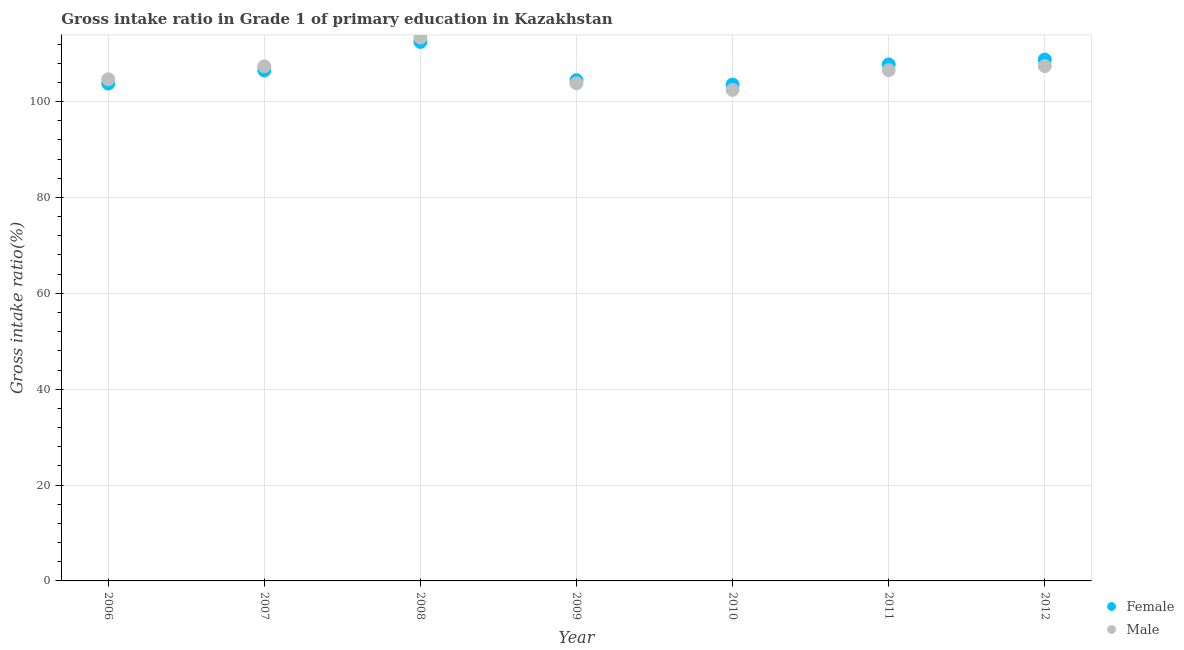Is the number of dotlines equal to the number of legend labels?
Your response must be concise. Yes. What is the gross intake ratio(male) in 2012?
Ensure brevity in your answer.  107.41. Across all years, what is the maximum gross intake ratio(female)?
Keep it short and to the point. 112.46. Across all years, what is the minimum gross intake ratio(female)?
Your answer should be compact. 103.54. In which year was the gross intake ratio(male) minimum?
Make the answer very short. 2010. What is the total gross intake ratio(female) in the graph?
Offer a terse response. 747.31. What is the difference between the gross intake ratio(female) in 2009 and that in 2011?
Keep it short and to the point. -3.28. What is the difference between the gross intake ratio(female) in 2007 and the gross intake ratio(male) in 2009?
Ensure brevity in your answer.  2.71. What is the average gross intake ratio(male) per year?
Offer a very short reply. 106.52. In the year 2009, what is the difference between the gross intake ratio(female) and gross intake ratio(male)?
Provide a succinct answer. 0.66. What is the ratio of the gross intake ratio(male) in 2009 to that in 2010?
Ensure brevity in your answer.  1.01. Is the difference between the gross intake ratio(female) in 2007 and 2011 greater than the difference between the gross intake ratio(male) in 2007 and 2011?
Keep it short and to the point. No. What is the difference between the highest and the second highest gross intake ratio(male)?
Your answer should be compact. 5.96. What is the difference between the highest and the lowest gross intake ratio(male)?
Your answer should be very brief. 10.94. How many dotlines are there?
Give a very brief answer. 2. Does the graph contain grids?
Your answer should be very brief. Yes. How many legend labels are there?
Ensure brevity in your answer.  2. What is the title of the graph?
Offer a terse response. Gross intake ratio in Grade 1 of primary education in Kazakhstan. What is the label or title of the Y-axis?
Ensure brevity in your answer.  Gross intake ratio(%). What is the Gross intake ratio(%) of Female in 2006?
Provide a succinct answer. 103.77. What is the Gross intake ratio(%) of Male in 2006?
Your response must be concise. 104.65. What is the Gross intake ratio(%) in Female in 2007?
Give a very brief answer. 106.53. What is the Gross intake ratio(%) in Male in 2007?
Ensure brevity in your answer.  107.36. What is the Gross intake ratio(%) in Female in 2008?
Offer a terse response. 112.46. What is the Gross intake ratio(%) in Male in 2008?
Your response must be concise. 113.38. What is the Gross intake ratio(%) in Female in 2009?
Offer a terse response. 104.47. What is the Gross intake ratio(%) of Male in 2009?
Provide a short and direct response. 103.82. What is the Gross intake ratio(%) of Female in 2010?
Your response must be concise. 103.54. What is the Gross intake ratio(%) of Male in 2010?
Provide a short and direct response. 102.44. What is the Gross intake ratio(%) in Female in 2011?
Offer a very short reply. 107.76. What is the Gross intake ratio(%) in Male in 2011?
Provide a succinct answer. 106.57. What is the Gross intake ratio(%) in Female in 2012?
Ensure brevity in your answer.  108.77. What is the Gross intake ratio(%) of Male in 2012?
Keep it short and to the point. 107.41. Across all years, what is the maximum Gross intake ratio(%) in Female?
Provide a short and direct response. 112.46. Across all years, what is the maximum Gross intake ratio(%) of Male?
Provide a short and direct response. 113.38. Across all years, what is the minimum Gross intake ratio(%) in Female?
Keep it short and to the point. 103.54. Across all years, what is the minimum Gross intake ratio(%) in Male?
Your answer should be compact. 102.44. What is the total Gross intake ratio(%) in Female in the graph?
Give a very brief answer. 747.31. What is the total Gross intake ratio(%) in Male in the graph?
Keep it short and to the point. 745.63. What is the difference between the Gross intake ratio(%) of Female in 2006 and that in 2007?
Make the answer very short. -2.76. What is the difference between the Gross intake ratio(%) of Male in 2006 and that in 2007?
Offer a very short reply. -2.7. What is the difference between the Gross intake ratio(%) of Female in 2006 and that in 2008?
Make the answer very short. -8.69. What is the difference between the Gross intake ratio(%) in Male in 2006 and that in 2008?
Provide a succinct answer. -8.72. What is the difference between the Gross intake ratio(%) in Female in 2006 and that in 2009?
Give a very brief answer. -0.7. What is the difference between the Gross intake ratio(%) of Male in 2006 and that in 2009?
Offer a very short reply. 0.83. What is the difference between the Gross intake ratio(%) of Female in 2006 and that in 2010?
Your answer should be very brief. 0.23. What is the difference between the Gross intake ratio(%) of Male in 2006 and that in 2010?
Your answer should be very brief. 2.21. What is the difference between the Gross intake ratio(%) in Female in 2006 and that in 2011?
Give a very brief answer. -3.98. What is the difference between the Gross intake ratio(%) in Male in 2006 and that in 2011?
Ensure brevity in your answer.  -1.92. What is the difference between the Gross intake ratio(%) in Female in 2006 and that in 2012?
Your response must be concise. -5. What is the difference between the Gross intake ratio(%) in Male in 2006 and that in 2012?
Your answer should be compact. -2.76. What is the difference between the Gross intake ratio(%) of Female in 2007 and that in 2008?
Ensure brevity in your answer.  -5.93. What is the difference between the Gross intake ratio(%) in Male in 2007 and that in 2008?
Ensure brevity in your answer.  -6.02. What is the difference between the Gross intake ratio(%) in Female in 2007 and that in 2009?
Ensure brevity in your answer.  2.05. What is the difference between the Gross intake ratio(%) in Male in 2007 and that in 2009?
Offer a terse response. 3.54. What is the difference between the Gross intake ratio(%) of Female in 2007 and that in 2010?
Make the answer very short. 2.99. What is the difference between the Gross intake ratio(%) in Male in 2007 and that in 2010?
Make the answer very short. 4.92. What is the difference between the Gross intake ratio(%) of Female in 2007 and that in 2011?
Give a very brief answer. -1.23. What is the difference between the Gross intake ratio(%) of Male in 2007 and that in 2011?
Your answer should be very brief. 0.79. What is the difference between the Gross intake ratio(%) in Female in 2007 and that in 2012?
Provide a succinct answer. -2.24. What is the difference between the Gross intake ratio(%) in Male in 2007 and that in 2012?
Give a very brief answer. -0.06. What is the difference between the Gross intake ratio(%) of Female in 2008 and that in 2009?
Your response must be concise. 7.99. What is the difference between the Gross intake ratio(%) of Male in 2008 and that in 2009?
Your response must be concise. 9.56. What is the difference between the Gross intake ratio(%) of Female in 2008 and that in 2010?
Provide a short and direct response. 8.92. What is the difference between the Gross intake ratio(%) of Male in 2008 and that in 2010?
Keep it short and to the point. 10.94. What is the difference between the Gross intake ratio(%) of Female in 2008 and that in 2011?
Give a very brief answer. 4.71. What is the difference between the Gross intake ratio(%) in Male in 2008 and that in 2011?
Provide a short and direct response. 6.81. What is the difference between the Gross intake ratio(%) of Female in 2008 and that in 2012?
Offer a terse response. 3.69. What is the difference between the Gross intake ratio(%) of Male in 2008 and that in 2012?
Provide a short and direct response. 5.96. What is the difference between the Gross intake ratio(%) in Female in 2009 and that in 2010?
Your answer should be very brief. 0.93. What is the difference between the Gross intake ratio(%) in Male in 2009 and that in 2010?
Your response must be concise. 1.38. What is the difference between the Gross intake ratio(%) of Female in 2009 and that in 2011?
Make the answer very short. -3.28. What is the difference between the Gross intake ratio(%) of Male in 2009 and that in 2011?
Your answer should be very brief. -2.75. What is the difference between the Gross intake ratio(%) in Female in 2009 and that in 2012?
Offer a terse response. -4.3. What is the difference between the Gross intake ratio(%) of Male in 2009 and that in 2012?
Provide a succinct answer. -3.6. What is the difference between the Gross intake ratio(%) of Female in 2010 and that in 2011?
Your answer should be compact. -4.22. What is the difference between the Gross intake ratio(%) of Male in 2010 and that in 2011?
Ensure brevity in your answer.  -4.13. What is the difference between the Gross intake ratio(%) in Female in 2010 and that in 2012?
Provide a succinct answer. -5.23. What is the difference between the Gross intake ratio(%) in Male in 2010 and that in 2012?
Offer a very short reply. -4.97. What is the difference between the Gross intake ratio(%) of Female in 2011 and that in 2012?
Your answer should be very brief. -1.02. What is the difference between the Gross intake ratio(%) in Male in 2011 and that in 2012?
Your answer should be very brief. -0.84. What is the difference between the Gross intake ratio(%) of Female in 2006 and the Gross intake ratio(%) of Male in 2007?
Your answer should be very brief. -3.58. What is the difference between the Gross intake ratio(%) in Female in 2006 and the Gross intake ratio(%) in Male in 2008?
Ensure brevity in your answer.  -9.6. What is the difference between the Gross intake ratio(%) of Female in 2006 and the Gross intake ratio(%) of Male in 2009?
Your response must be concise. -0.04. What is the difference between the Gross intake ratio(%) in Female in 2006 and the Gross intake ratio(%) in Male in 2010?
Make the answer very short. 1.33. What is the difference between the Gross intake ratio(%) of Female in 2006 and the Gross intake ratio(%) of Male in 2011?
Make the answer very short. -2.8. What is the difference between the Gross intake ratio(%) in Female in 2006 and the Gross intake ratio(%) in Male in 2012?
Give a very brief answer. -3.64. What is the difference between the Gross intake ratio(%) in Female in 2007 and the Gross intake ratio(%) in Male in 2008?
Ensure brevity in your answer.  -6.85. What is the difference between the Gross intake ratio(%) of Female in 2007 and the Gross intake ratio(%) of Male in 2009?
Provide a short and direct response. 2.71. What is the difference between the Gross intake ratio(%) of Female in 2007 and the Gross intake ratio(%) of Male in 2010?
Provide a short and direct response. 4.09. What is the difference between the Gross intake ratio(%) in Female in 2007 and the Gross intake ratio(%) in Male in 2011?
Ensure brevity in your answer.  -0.04. What is the difference between the Gross intake ratio(%) of Female in 2007 and the Gross intake ratio(%) of Male in 2012?
Offer a terse response. -0.89. What is the difference between the Gross intake ratio(%) of Female in 2008 and the Gross intake ratio(%) of Male in 2009?
Ensure brevity in your answer.  8.64. What is the difference between the Gross intake ratio(%) of Female in 2008 and the Gross intake ratio(%) of Male in 2010?
Offer a very short reply. 10.02. What is the difference between the Gross intake ratio(%) in Female in 2008 and the Gross intake ratio(%) in Male in 2011?
Offer a very short reply. 5.89. What is the difference between the Gross intake ratio(%) in Female in 2008 and the Gross intake ratio(%) in Male in 2012?
Provide a succinct answer. 5.05. What is the difference between the Gross intake ratio(%) in Female in 2009 and the Gross intake ratio(%) in Male in 2010?
Offer a very short reply. 2.03. What is the difference between the Gross intake ratio(%) in Female in 2009 and the Gross intake ratio(%) in Male in 2011?
Ensure brevity in your answer.  -2.1. What is the difference between the Gross intake ratio(%) of Female in 2009 and the Gross intake ratio(%) of Male in 2012?
Your answer should be compact. -2.94. What is the difference between the Gross intake ratio(%) in Female in 2010 and the Gross intake ratio(%) in Male in 2011?
Your response must be concise. -3.03. What is the difference between the Gross intake ratio(%) in Female in 2010 and the Gross intake ratio(%) in Male in 2012?
Provide a short and direct response. -3.87. What is the difference between the Gross intake ratio(%) in Female in 2011 and the Gross intake ratio(%) in Male in 2012?
Your answer should be very brief. 0.34. What is the average Gross intake ratio(%) of Female per year?
Your answer should be compact. 106.76. What is the average Gross intake ratio(%) of Male per year?
Your response must be concise. 106.52. In the year 2006, what is the difference between the Gross intake ratio(%) of Female and Gross intake ratio(%) of Male?
Provide a short and direct response. -0.88. In the year 2007, what is the difference between the Gross intake ratio(%) of Female and Gross intake ratio(%) of Male?
Ensure brevity in your answer.  -0.83. In the year 2008, what is the difference between the Gross intake ratio(%) in Female and Gross intake ratio(%) in Male?
Make the answer very short. -0.91. In the year 2009, what is the difference between the Gross intake ratio(%) of Female and Gross intake ratio(%) of Male?
Your answer should be very brief. 0.66. In the year 2010, what is the difference between the Gross intake ratio(%) of Female and Gross intake ratio(%) of Male?
Your answer should be compact. 1.1. In the year 2011, what is the difference between the Gross intake ratio(%) in Female and Gross intake ratio(%) in Male?
Make the answer very short. 1.19. In the year 2012, what is the difference between the Gross intake ratio(%) in Female and Gross intake ratio(%) in Male?
Give a very brief answer. 1.36. What is the ratio of the Gross intake ratio(%) of Female in 2006 to that in 2007?
Your response must be concise. 0.97. What is the ratio of the Gross intake ratio(%) in Male in 2006 to that in 2007?
Make the answer very short. 0.97. What is the ratio of the Gross intake ratio(%) in Female in 2006 to that in 2008?
Offer a terse response. 0.92. What is the ratio of the Gross intake ratio(%) in Male in 2006 to that in 2008?
Offer a very short reply. 0.92. What is the ratio of the Gross intake ratio(%) in Male in 2006 to that in 2009?
Provide a short and direct response. 1.01. What is the ratio of the Gross intake ratio(%) of Female in 2006 to that in 2010?
Offer a terse response. 1. What is the ratio of the Gross intake ratio(%) of Male in 2006 to that in 2010?
Offer a terse response. 1.02. What is the ratio of the Gross intake ratio(%) of Female in 2006 to that in 2011?
Provide a short and direct response. 0.96. What is the ratio of the Gross intake ratio(%) of Female in 2006 to that in 2012?
Your response must be concise. 0.95. What is the ratio of the Gross intake ratio(%) of Male in 2006 to that in 2012?
Offer a very short reply. 0.97. What is the ratio of the Gross intake ratio(%) in Female in 2007 to that in 2008?
Offer a terse response. 0.95. What is the ratio of the Gross intake ratio(%) of Male in 2007 to that in 2008?
Offer a terse response. 0.95. What is the ratio of the Gross intake ratio(%) in Female in 2007 to that in 2009?
Your answer should be very brief. 1.02. What is the ratio of the Gross intake ratio(%) in Male in 2007 to that in 2009?
Ensure brevity in your answer.  1.03. What is the ratio of the Gross intake ratio(%) of Female in 2007 to that in 2010?
Keep it short and to the point. 1.03. What is the ratio of the Gross intake ratio(%) of Male in 2007 to that in 2010?
Provide a short and direct response. 1.05. What is the ratio of the Gross intake ratio(%) in Male in 2007 to that in 2011?
Your answer should be compact. 1.01. What is the ratio of the Gross intake ratio(%) in Female in 2007 to that in 2012?
Ensure brevity in your answer.  0.98. What is the ratio of the Gross intake ratio(%) of Female in 2008 to that in 2009?
Provide a succinct answer. 1.08. What is the ratio of the Gross intake ratio(%) in Male in 2008 to that in 2009?
Keep it short and to the point. 1.09. What is the ratio of the Gross intake ratio(%) of Female in 2008 to that in 2010?
Keep it short and to the point. 1.09. What is the ratio of the Gross intake ratio(%) in Male in 2008 to that in 2010?
Make the answer very short. 1.11. What is the ratio of the Gross intake ratio(%) in Female in 2008 to that in 2011?
Ensure brevity in your answer.  1.04. What is the ratio of the Gross intake ratio(%) of Male in 2008 to that in 2011?
Offer a terse response. 1.06. What is the ratio of the Gross intake ratio(%) in Female in 2008 to that in 2012?
Your answer should be compact. 1.03. What is the ratio of the Gross intake ratio(%) in Male in 2008 to that in 2012?
Provide a short and direct response. 1.06. What is the ratio of the Gross intake ratio(%) in Female in 2009 to that in 2010?
Your response must be concise. 1.01. What is the ratio of the Gross intake ratio(%) in Male in 2009 to that in 2010?
Keep it short and to the point. 1.01. What is the ratio of the Gross intake ratio(%) in Female in 2009 to that in 2011?
Provide a short and direct response. 0.97. What is the ratio of the Gross intake ratio(%) of Male in 2009 to that in 2011?
Give a very brief answer. 0.97. What is the ratio of the Gross intake ratio(%) of Female in 2009 to that in 2012?
Keep it short and to the point. 0.96. What is the ratio of the Gross intake ratio(%) in Male in 2009 to that in 2012?
Offer a very short reply. 0.97. What is the ratio of the Gross intake ratio(%) in Female in 2010 to that in 2011?
Give a very brief answer. 0.96. What is the ratio of the Gross intake ratio(%) of Male in 2010 to that in 2011?
Provide a short and direct response. 0.96. What is the ratio of the Gross intake ratio(%) in Female in 2010 to that in 2012?
Provide a succinct answer. 0.95. What is the ratio of the Gross intake ratio(%) in Male in 2010 to that in 2012?
Offer a terse response. 0.95. What is the ratio of the Gross intake ratio(%) in Male in 2011 to that in 2012?
Ensure brevity in your answer.  0.99. What is the difference between the highest and the second highest Gross intake ratio(%) of Female?
Your answer should be very brief. 3.69. What is the difference between the highest and the second highest Gross intake ratio(%) in Male?
Give a very brief answer. 5.96. What is the difference between the highest and the lowest Gross intake ratio(%) of Female?
Offer a terse response. 8.92. What is the difference between the highest and the lowest Gross intake ratio(%) of Male?
Ensure brevity in your answer.  10.94. 